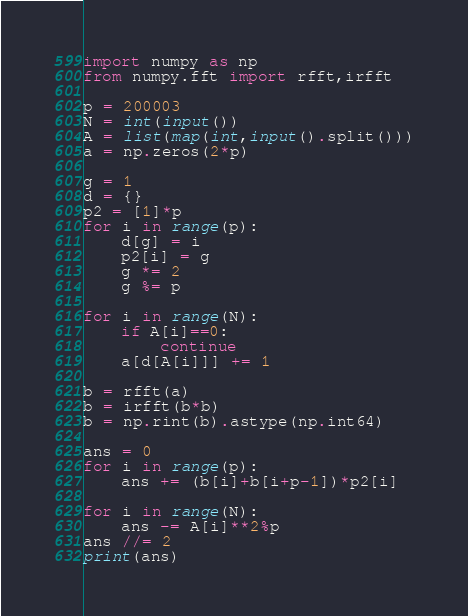Convert code to text. <code><loc_0><loc_0><loc_500><loc_500><_Python_>import numpy as np
from numpy.fft import rfft,irfft

p = 200003
N = int(input())
A = list(map(int,input().split()))
a = np.zeros(2*p)

g = 1
d = {}
p2 = [1]*p
for i in range(p):
    d[g] = i
    p2[i] = g
    g *= 2
    g %= p

for i in range(N):
    if A[i]==0:
        continue
    a[d[A[i]]] += 1

b = rfft(a)
b = irfft(b*b)
b = np.rint(b).astype(np.int64)

ans = 0
for i in range(p):
    ans += (b[i]+b[i+p-1])*p2[i]

for i in range(N):
    ans -= A[i]**2%p
ans //= 2
print(ans)</code> 